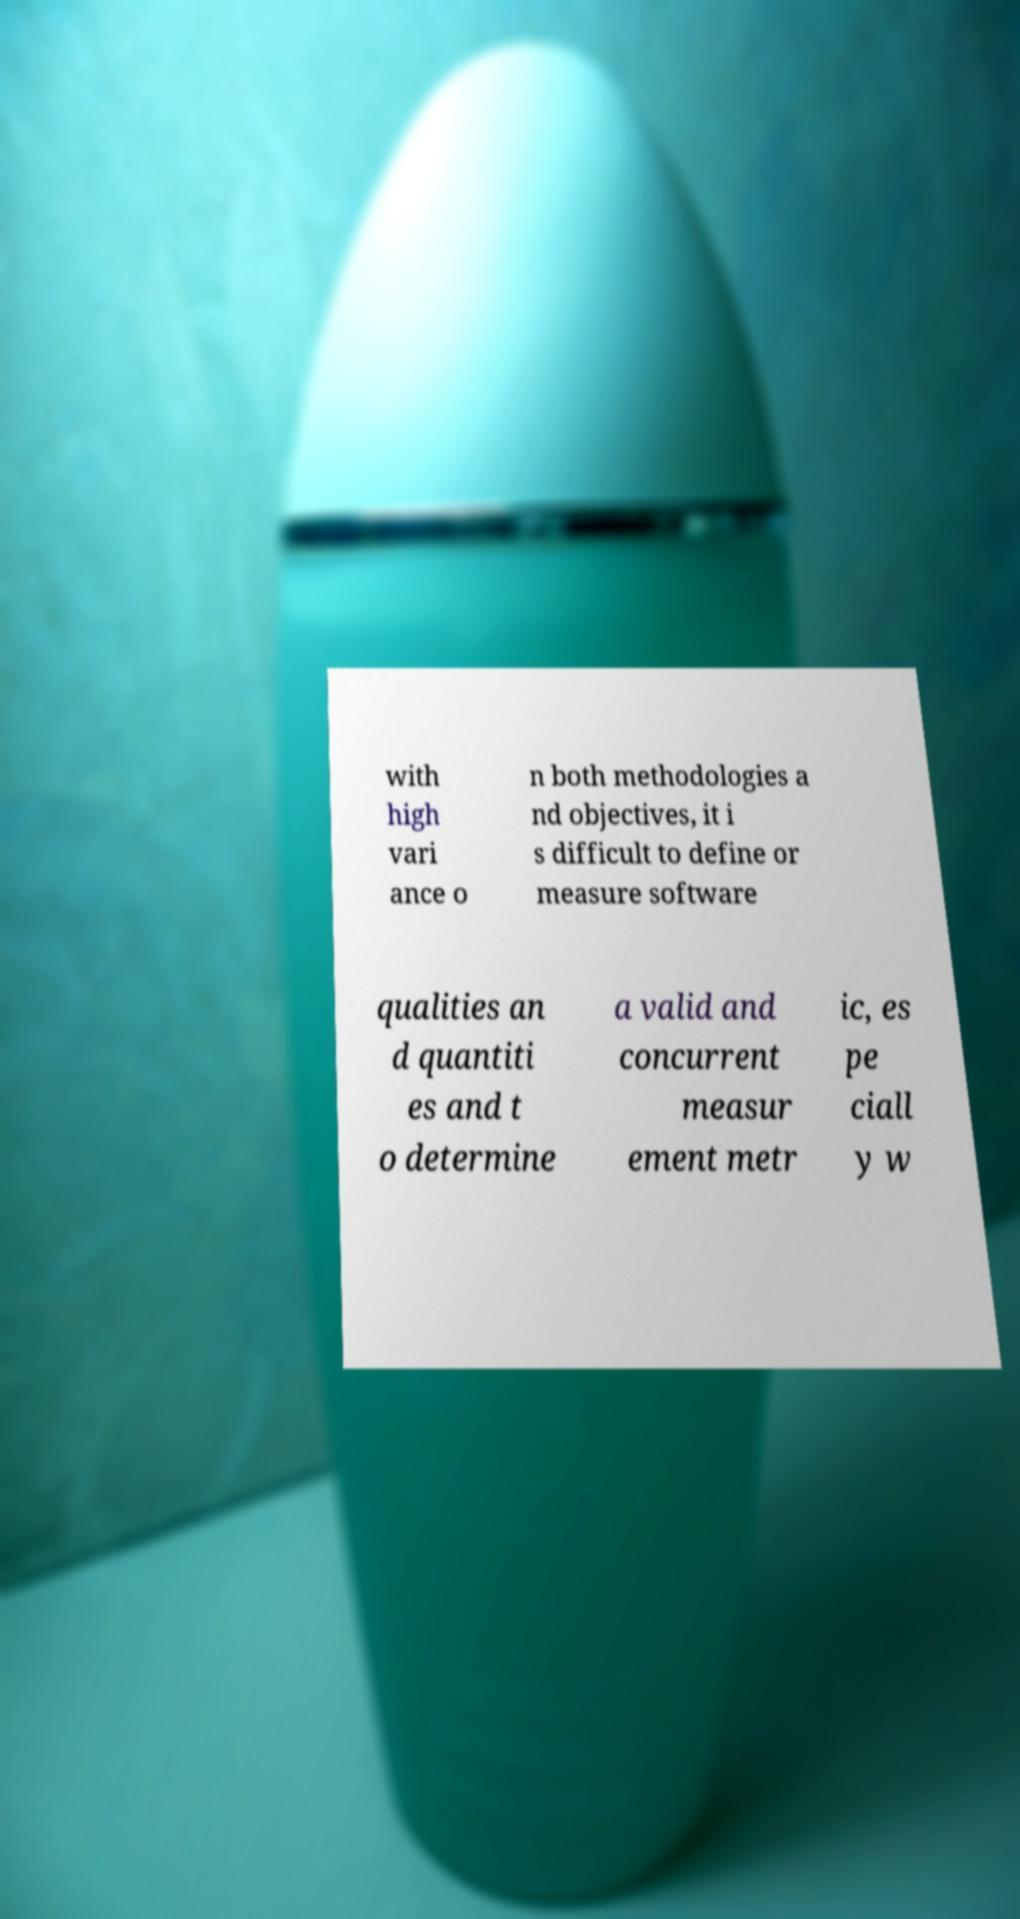Could you extract and type out the text from this image? with high vari ance o n both methodologies a nd objectives, it i s difficult to define or measure software qualities an d quantiti es and t o determine a valid and concurrent measur ement metr ic, es pe ciall y w 